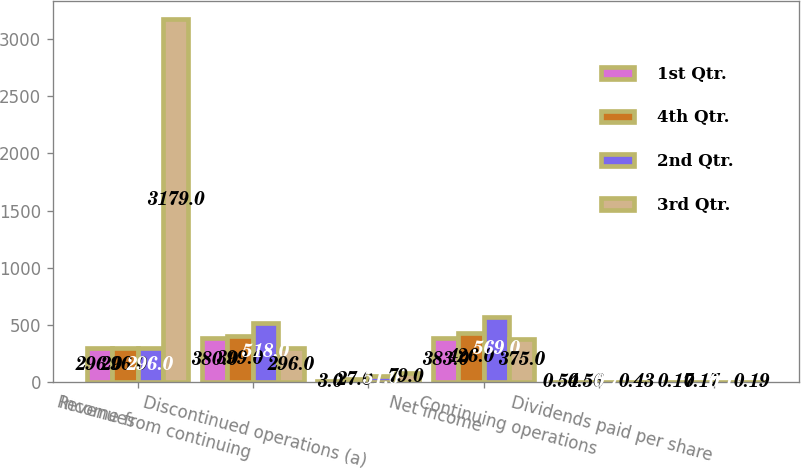<chart> <loc_0><loc_0><loc_500><loc_500><stacked_bar_chart><ecel><fcel>Revenues<fcel>Income from continuing<fcel>Discontinued operations (a)<fcel>Net income<fcel>Continuing operations<fcel>Dividends paid per share<nl><fcel>1st Qtr.<fcel>296<fcel>380<fcel>3<fcel>383<fcel>0.54<fcel>0.17<nl><fcel>4th Qtr.<fcel>296<fcel>399<fcel>27<fcel>426<fcel>0.56<fcel>0.17<nl><fcel>2nd Qtr.<fcel>296<fcel>518<fcel>51<fcel>569<fcel>0.73<fcel>0.19<nl><fcel>3rd Qtr.<fcel>3179<fcel>296<fcel>79<fcel>375<fcel>0.43<fcel>0.19<nl></chart> 